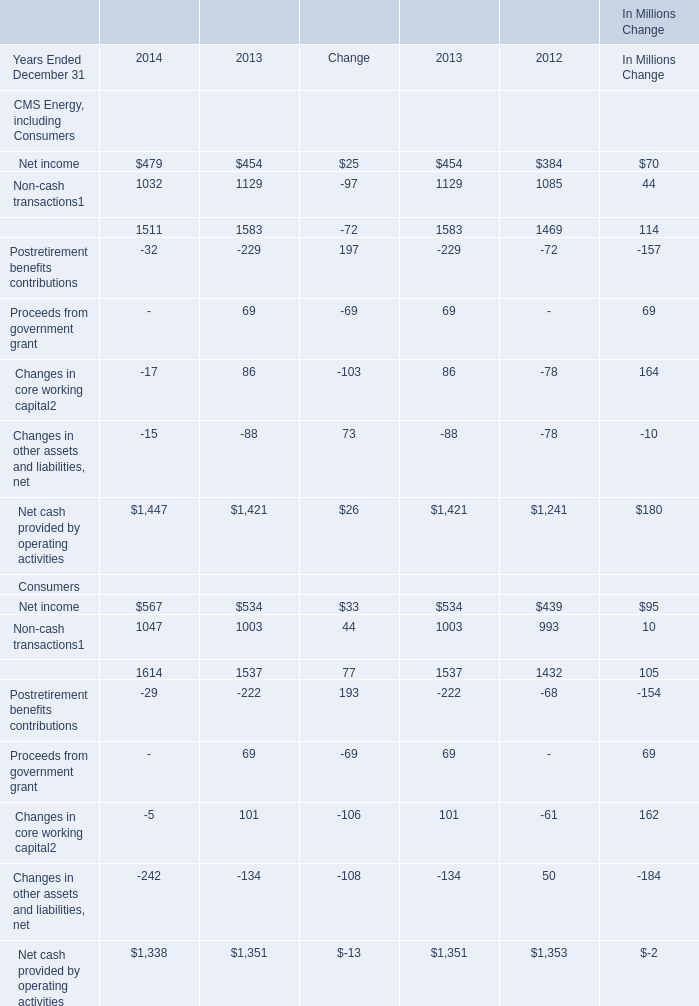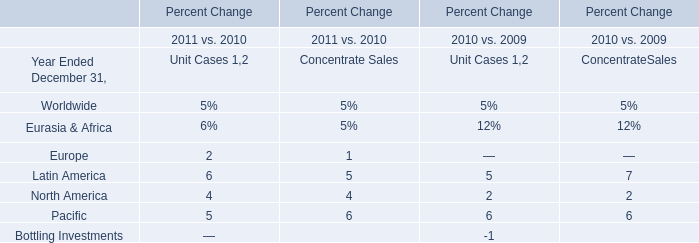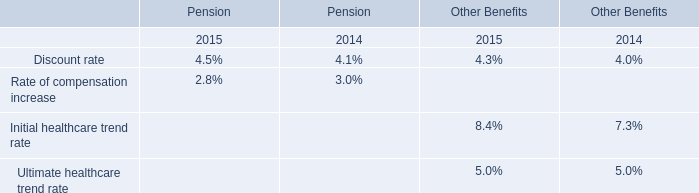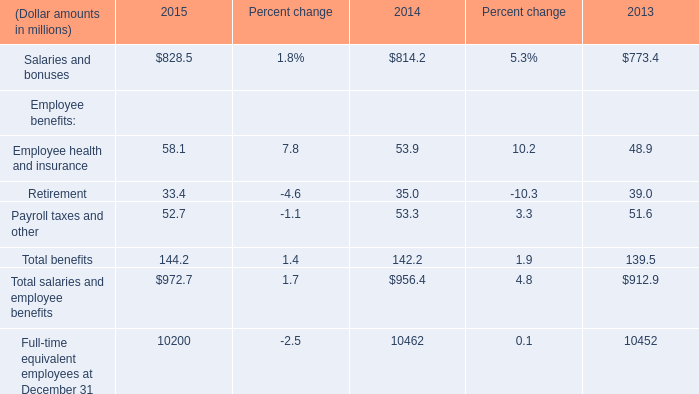In the year with the most Retirement in Table 3, what is the growth rate of Net income of CMS Energy, including Consumers in Table 0? 
Computations: ((454 - 384) / 384)
Answer: 0.18229. 